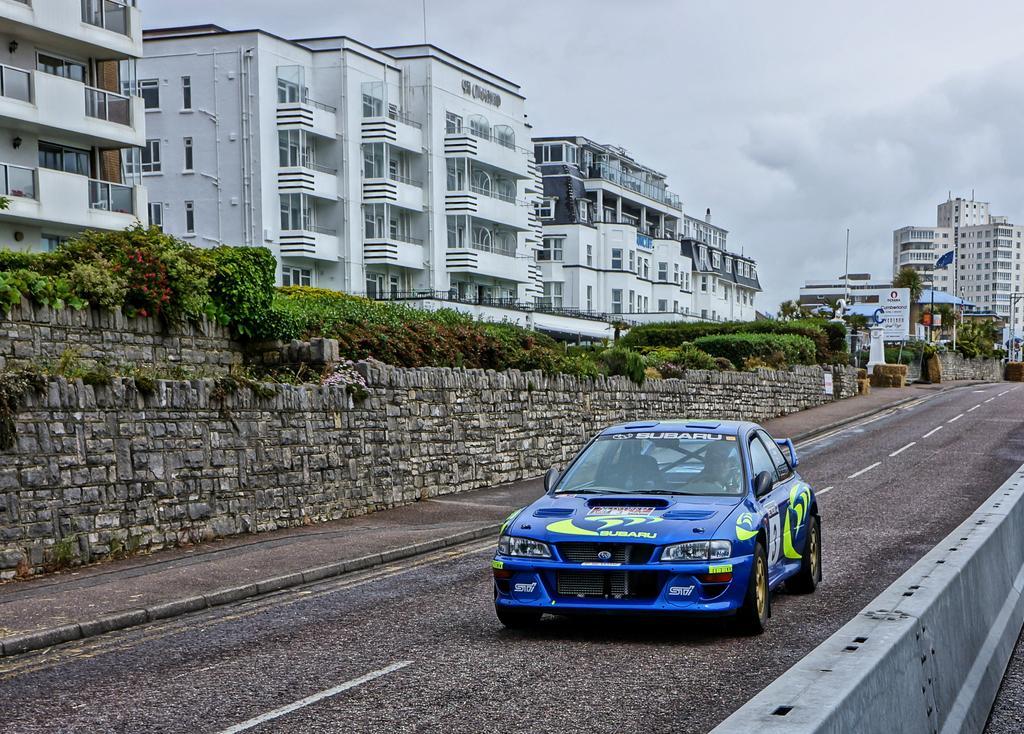Please provide a concise description of this image. As we can see in the image there are rocks, buildings, plants, trees, banner, blue color car, sky and clouds. 